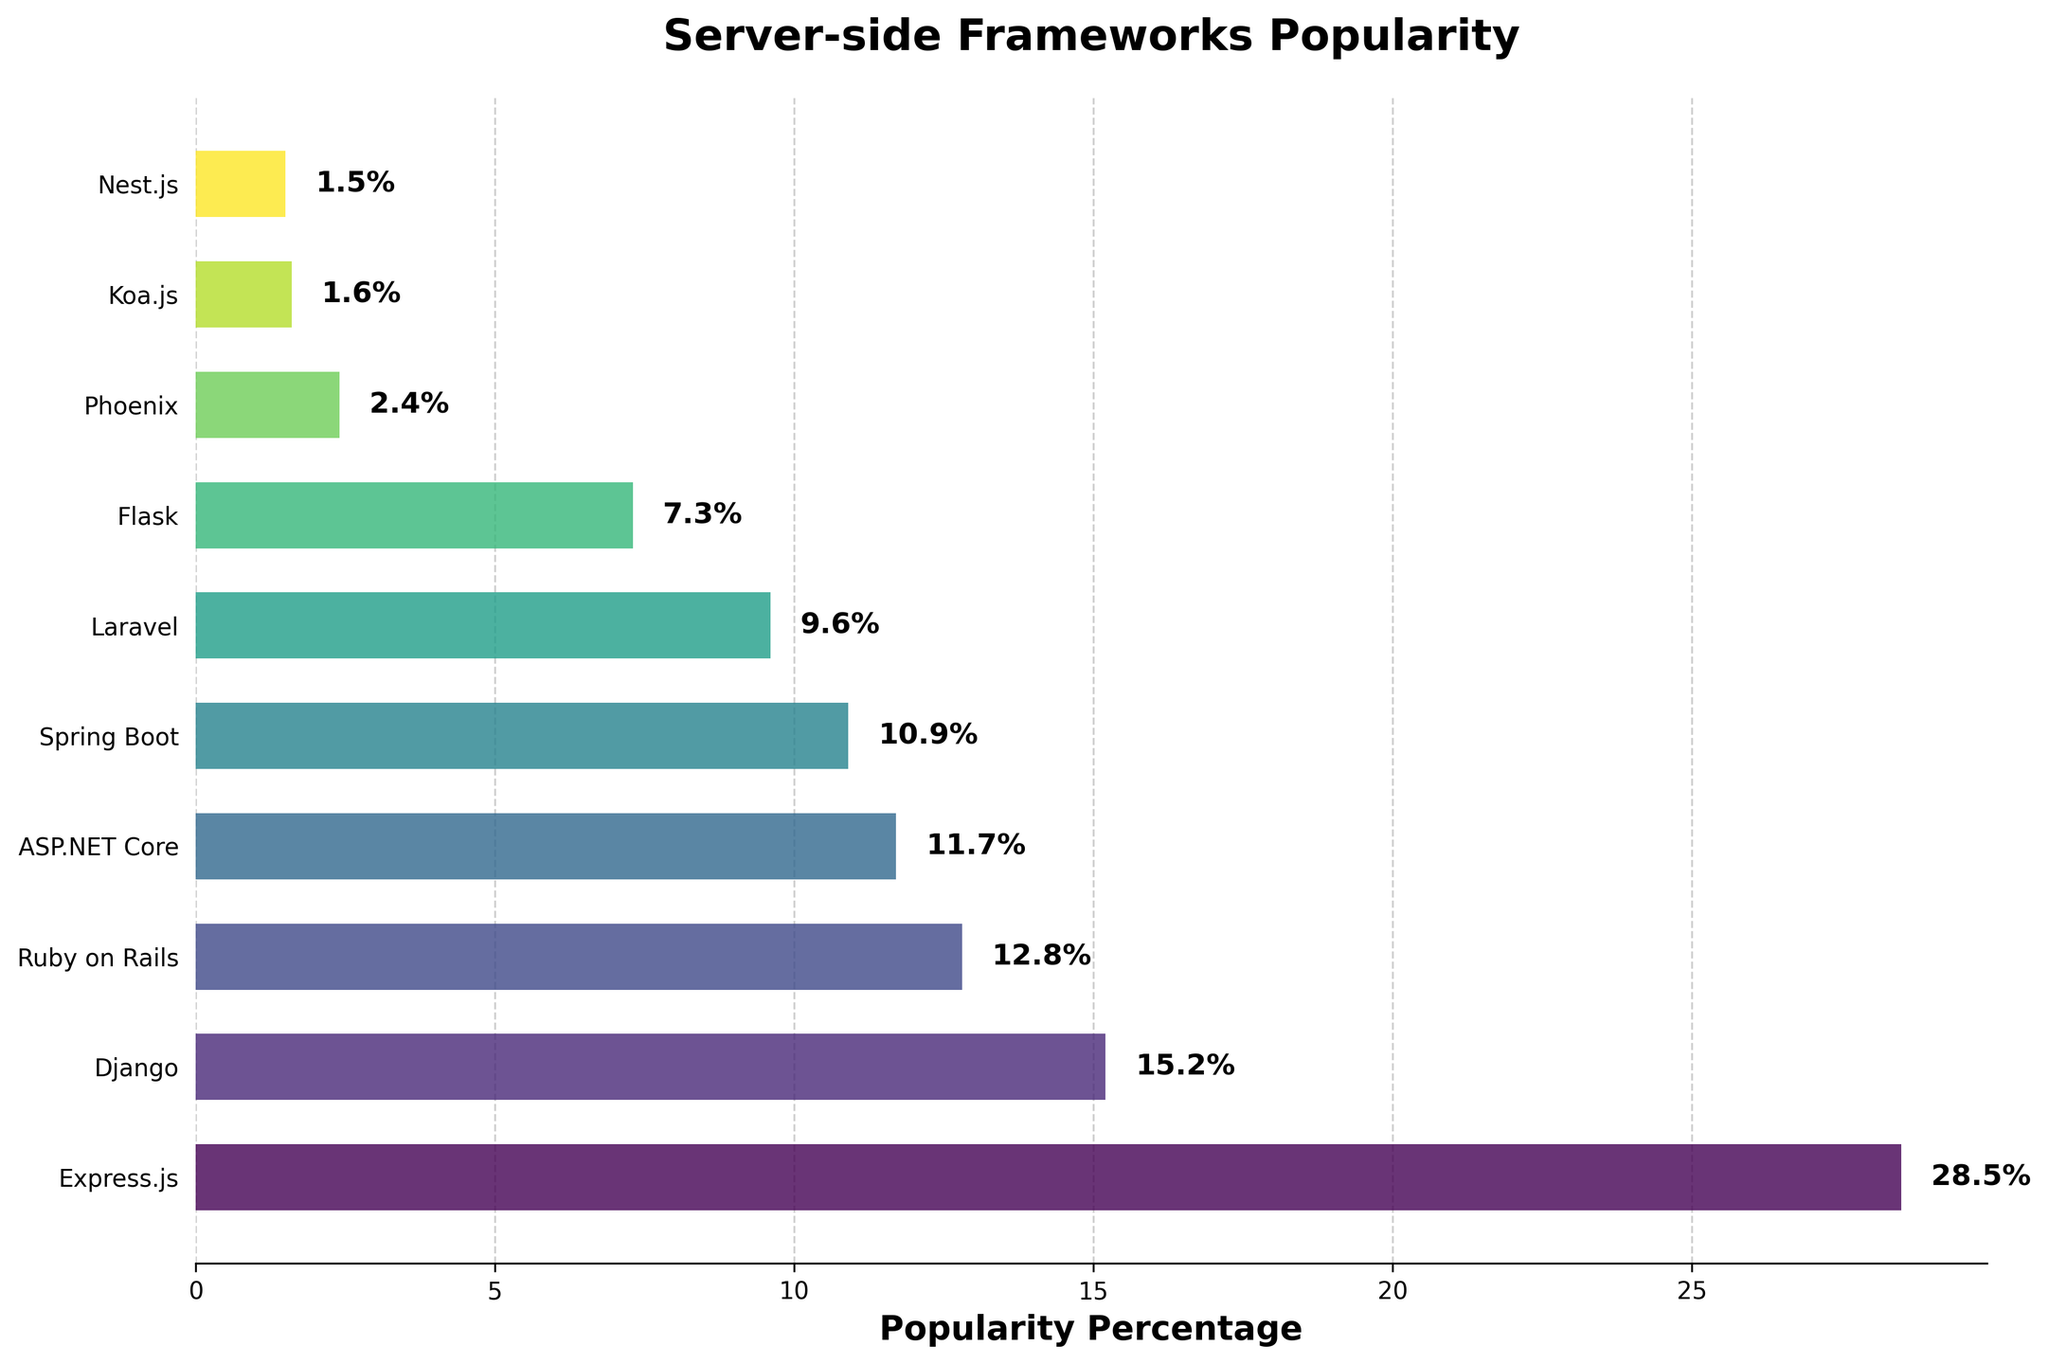Which framework is the most popular? Identify the bar with the greatest length. Express.js has the longest bar with a value of 28.5%.
Answer: Express.js What percentage of developers use Django? Look at the label next to the bar for Django. The label indicates 15.2%.
Answer: 15.2% Which framework is the least popular? Identify the bar with the shortest length. Nest.js has the shortest bar with a value of 1.5%.
Answer: Nest.js Is the popularity of Django greater than the combined popularity of Phoenix and Koa.js? Calculate the combined percentage for Phoenix and Koa.js (2.4% + 1.6% = 4.0%) and compare it to Django's 15.2%. Django's percentage is greater.
Answer: Yes How much more popular is Express.js compared to Laravel? Subtract Laravel's percentage from Express.js's percentage (28.5% - 9.6% = 18.9%).
Answer: 18.9% What is the combined popularity percentage of the top three frameworks? Sum the percentages of Express.js, Django, and Ruby on Rails (28.5% + 15.2% + 12.8% = 56.5%).
Answer: 56.5% Which server-side framework has a popularity close to 10%? Look at bars around the 10% mark. Spring Boot has a percentage of 10.9%.
Answer: Spring Boot What is the difference in popularity between Flask and Ruby on Rails? Subtract Flask's percentage from Ruby on Rails's percentage (12.8% - 7.3% = 5.5%).
Answer: 5.5% How many frameworks have a popularity percentage greater than 10%? Count the bars with percentages greater than 10%. There are four such bars: Express.js, Django, Ruby on Rails, and ASP.NET Core.
Answer: 4 Which framework has a popularity half of that of Django’s? Identify the bar that has approximately half the percentage of Django (15.2% / 2 = 7.6%). Flask, with 7.3%, is the closest.
Answer: Flask 